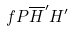Convert formula to latex. <formula><loc_0><loc_0><loc_500><loc_500>f P \overline { H } ^ { \prime } H ^ { \prime }</formula> 